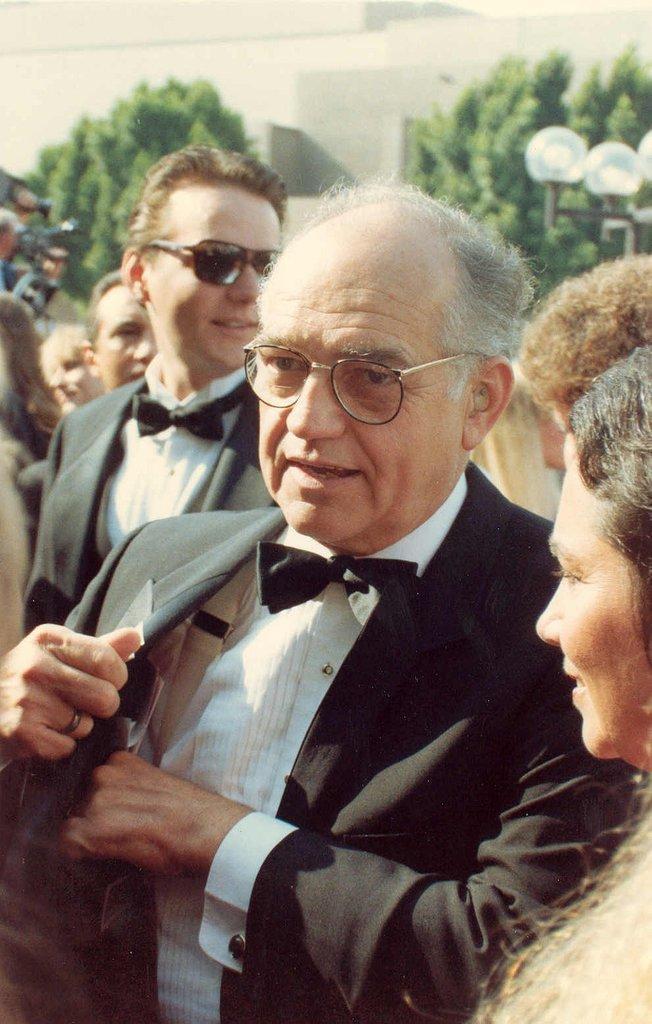Could you give a brief overview of what you see in this image? In this image we can see a few people standing, among them, some are wearing the spectacles, there are some trees, poles and lights, in the background, we can see the wall. 